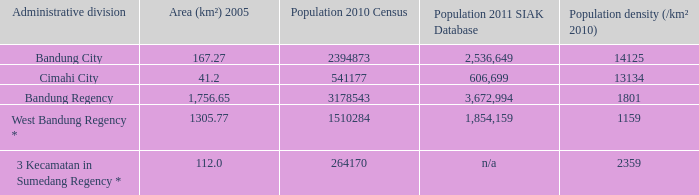Which administrative division had a 2011 population of 606,699 according to the siak database? Cimahi City. 